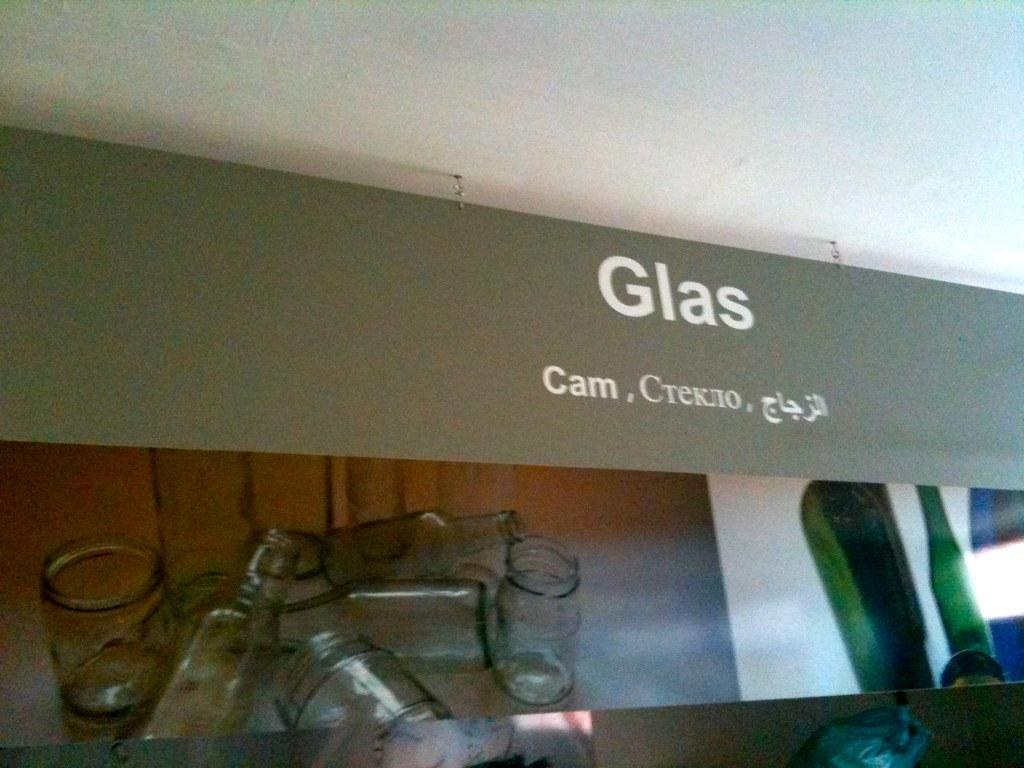What type of objects are depicted in the pictures in the image? There are pictures of bottles and glasses in the image. Is there any text present in the image? Yes, the word "Glass" is written in the image. Can you describe the discussion between the squirrel and the stretch in the image? There is no discussion, squirrel, or stretch present in the image; it only contains pictures of bottles and glasses, along with the word "Glass." 